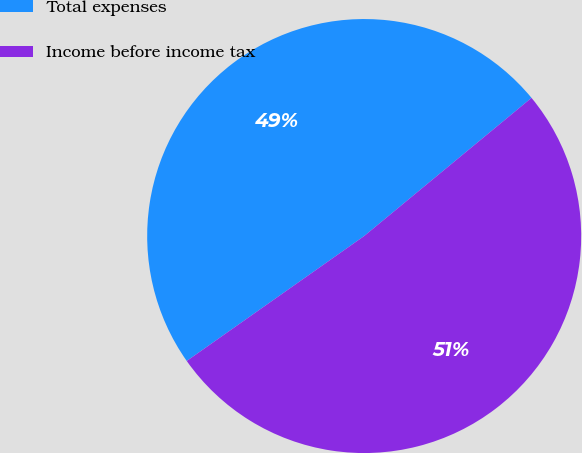Convert chart to OTSL. <chart><loc_0><loc_0><loc_500><loc_500><pie_chart><fcel>Total expenses<fcel>Income before income tax<nl><fcel>48.78%<fcel>51.22%<nl></chart> 